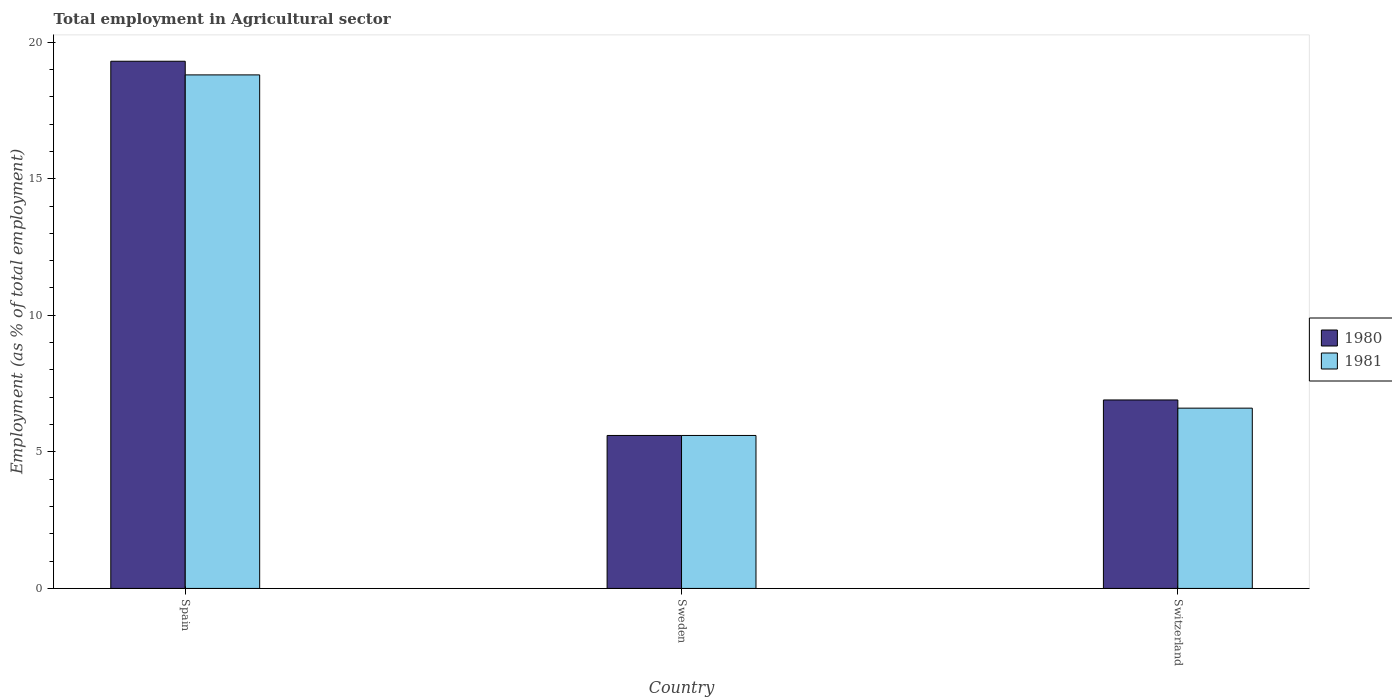How many different coloured bars are there?
Your answer should be compact. 2. How many groups of bars are there?
Your response must be concise. 3. Are the number of bars per tick equal to the number of legend labels?
Your answer should be compact. Yes. What is the label of the 1st group of bars from the left?
Your answer should be very brief. Spain. What is the employment in agricultural sector in 1981 in Sweden?
Offer a very short reply. 5.6. Across all countries, what is the maximum employment in agricultural sector in 1980?
Offer a very short reply. 19.3. Across all countries, what is the minimum employment in agricultural sector in 1981?
Your answer should be compact. 5.6. In which country was the employment in agricultural sector in 1980 maximum?
Your answer should be compact. Spain. What is the total employment in agricultural sector in 1981 in the graph?
Offer a very short reply. 31. What is the difference between the employment in agricultural sector in 1981 in Spain and that in Switzerland?
Offer a very short reply. 12.2. What is the difference between the employment in agricultural sector in 1981 in Sweden and the employment in agricultural sector in 1980 in Switzerland?
Your response must be concise. -1.3. What is the average employment in agricultural sector in 1980 per country?
Offer a very short reply. 10.6. What is the difference between the employment in agricultural sector of/in 1980 and employment in agricultural sector of/in 1981 in Sweden?
Provide a succinct answer. 0. What is the ratio of the employment in agricultural sector in 1980 in Spain to that in Switzerland?
Your response must be concise. 2.8. Is the employment in agricultural sector in 1981 in Spain less than that in Sweden?
Provide a short and direct response. No. What is the difference between the highest and the second highest employment in agricultural sector in 1981?
Make the answer very short. 13.2. What is the difference between the highest and the lowest employment in agricultural sector in 1980?
Your response must be concise. 13.7. In how many countries, is the employment in agricultural sector in 1981 greater than the average employment in agricultural sector in 1981 taken over all countries?
Your answer should be compact. 1. What does the 2nd bar from the right in Spain represents?
Make the answer very short. 1980. Are all the bars in the graph horizontal?
Offer a terse response. No. How many legend labels are there?
Your response must be concise. 2. How are the legend labels stacked?
Offer a terse response. Vertical. What is the title of the graph?
Ensure brevity in your answer.  Total employment in Agricultural sector. What is the label or title of the Y-axis?
Keep it short and to the point. Employment (as % of total employment). What is the Employment (as % of total employment) in 1980 in Spain?
Provide a short and direct response. 19.3. What is the Employment (as % of total employment) in 1981 in Spain?
Make the answer very short. 18.8. What is the Employment (as % of total employment) of 1980 in Sweden?
Provide a succinct answer. 5.6. What is the Employment (as % of total employment) in 1981 in Sweden?
Keep it short and to the point. 5.6. What is the Employment (as % of total employment) of 1980 in Switzerland?
Provide a short and direct response. 6.9. What is the Employment (as % of total employment) of 1981 in Switzerland?
Provide a succinct answer. 6.6. Across all countries, what is the maximum Employment (as % of total employment) in 1980?
Give a very brief answer. 19.3. Across all countries, what is the maximum Employment (as % of total employment) in 1981?
Keep it short and to the point. 18.8. Across all countries, what is the minimum Employment (as % of total employment) in 1980?
Your answer should be compact. 5.6. Across all countries, what is the minimum Employment (as % of total employment) of 1981?
Give a very brief answer. 5.6. What is the total Employment (as % of total employment) of 1980 in the graph?
Ensure brevity in your answer.  31.8. What is the total Employment (as % of total employment) in 1981 in the graph?
Make the answer very short. 31. What is the difference between the Employment (as % of total employment) of 1981 in Spain and that in Sweden?
Offer a very short reply. 13.2. What is the difference between the Employment (as % of total employment) in 1980 in Spain and that in Switzerland?
Give a very brief answer. 12.4. What is the difference between the Employment (as % of total employment) in 1980 in Spain and the Employment (as % of total employment) in 1981 in Sweden?
Offer a terse response. 13.7. What is the difference between the Employment (as % of total employment) in 1980 in Spain and the Employment (as % of total employment) in 1981 in Switzerland?
Offer a very short reply. 12.7. What is the average Employment (as % of total employment) of 1980 per country?
Offer a terse response. 10.6. What is the average Employment (as % of total employment) of 1981 per country?
Your answer should be very brief. 10.33. What is the ratio of the Employment (as % of total employment) in 1980 in Spain to that in Sweden?
Make the answer very short. 3.45. What is the ratio of the Employment (as % of total employment) in 1981 in Spain to that in Sweden?
Provide a succinct answer. 3.36. What is the ratio of the Employment (as % of total employment) in 1980 in Spain to that in Switzerland?
Your answer should be compact. 2.8. What is the ratio of the Employment (as % of total employment) of 1981 in Spain to that in Switzerland?
Offer a terse response. 2.85. What is the ratio of the Employment (as % of total employment) in 1980 in Sweden to that in Switzerland?
Give a very brief answer. 0.81. What is the ratio of the Employment (as % of total employment) in 1981 in Sweden to that in Switzerland?
Offer a terse response. 0.85. What is the difference between the highest and the second highest Employment (as % of total employment) in 1981?
Provide a succinct answer. 12.2. 